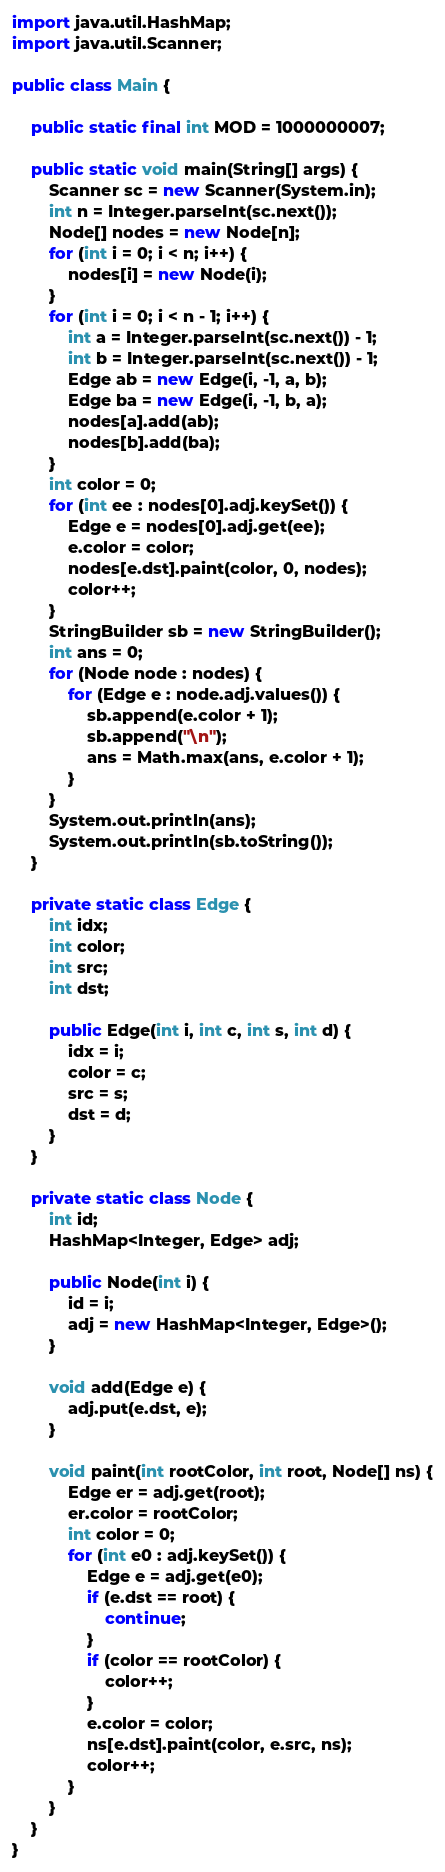Convert code to text. <code><loc_0><loc_0><loc_500><loc_500><_Java_>import java.util.HashMap;
import java.util.Scanner;

public class Main {

    public static final int MOD = 1000000007;

    public static void main(String[] args) {
        Scanner sc = new Scanner(System.in);
        int n = Integer.parseInt(sc.next());
        Node[] nodes = new Node[n];
        for (int i = 0; i < n; i++) {
            nodes[i] = new Node(i);
        }
        for (int i = 0; i < n - 1; i++) {
            int a = Integer.parseInt(sc.next()) - 1;
            int b = Integer.parseInt(sc.next()) - 1;
            Edge ab = new Edge(i, -1, a, b);
            Edge ba = new Edge(i, -1, b, a);
            nodes[a].add(ab);
            nodes[b].add(ba);
        }
        int color = 0;
        for (int ee : nodes[0].adj.keySet()) {
            Edge e = nodes[0].adj.get(ee);
            e.color = color;
            nodes[e.dst].paint(color, 0, nodes);
            color++;
        }
        StringBuilder sb = new StringBuilder();
        int ans = 0;
        for (Node node : nodes) {
            for (Edge e : node.adj.values()) {
                sb.append(e.color + 1);
                sb.append("\n");
                ans = Math.max(ans, e.color + 1);
            }
        }
        System.out.println(ans);
        System.out.println(sb.toString());
    }

    private static class Edge {
        int idx;
        int color;
        int src;
        int dst;

        public Edge(int i, int c, int s, int d) {
            idx = i;
            color = c;
            src = s;
            dst = d;
        }
    }

    private static class Node {
        int id;
        HashMap<Integer, Edge> adj;

        public Node(int i) {
            id = i;
            adj = new HashMap<Integer, Edge>();
        }

        void add(Edge e) {
            adj.put(e.dst, e);
        }

        void paint(int rootColor, int root, Node[] ns) {
            Edge er = adj.get(root);
            er.color = rootColor;
            int color = 0;
            for (int e0 : adj.keySet()) {
                Edge e = adj.get(e0);
                if (e.dst == root) {
                    continue;
                }
                if (color == rootColor) {
                    color++;
                }
                e.color = color;
                ns[e.dst].paint(color, e.src, ns);
                color++;
            }
        }
    }
}</code> 